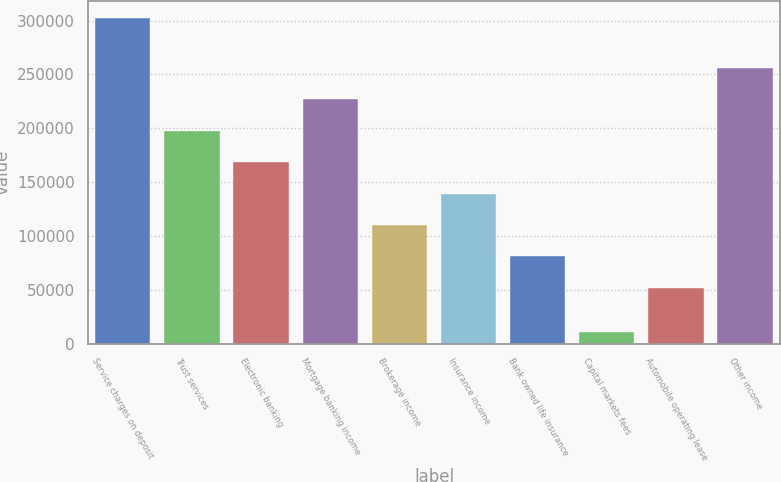<chart> <loc_0><loc_0><loc_500><loc_500><bar_chart><fcel>Service charges on deposit<fcel>Trust services<fcel>Electronic banking<fcel>Mortgage banking income<fcel>Brokerage income<fcel>Insurance income<fcel>Bank owned life insurance<fcel>Capital markets fees<fcel>Automobile operating lease<fcel>Other income<nl><fcel>302799<fcel>197784<fcel>168589<fcel>226979<fcel>110200<fcel>139394<fcel>81004.8<fcel>10851<fcel>51810<fcel>256174<nl></chart> 